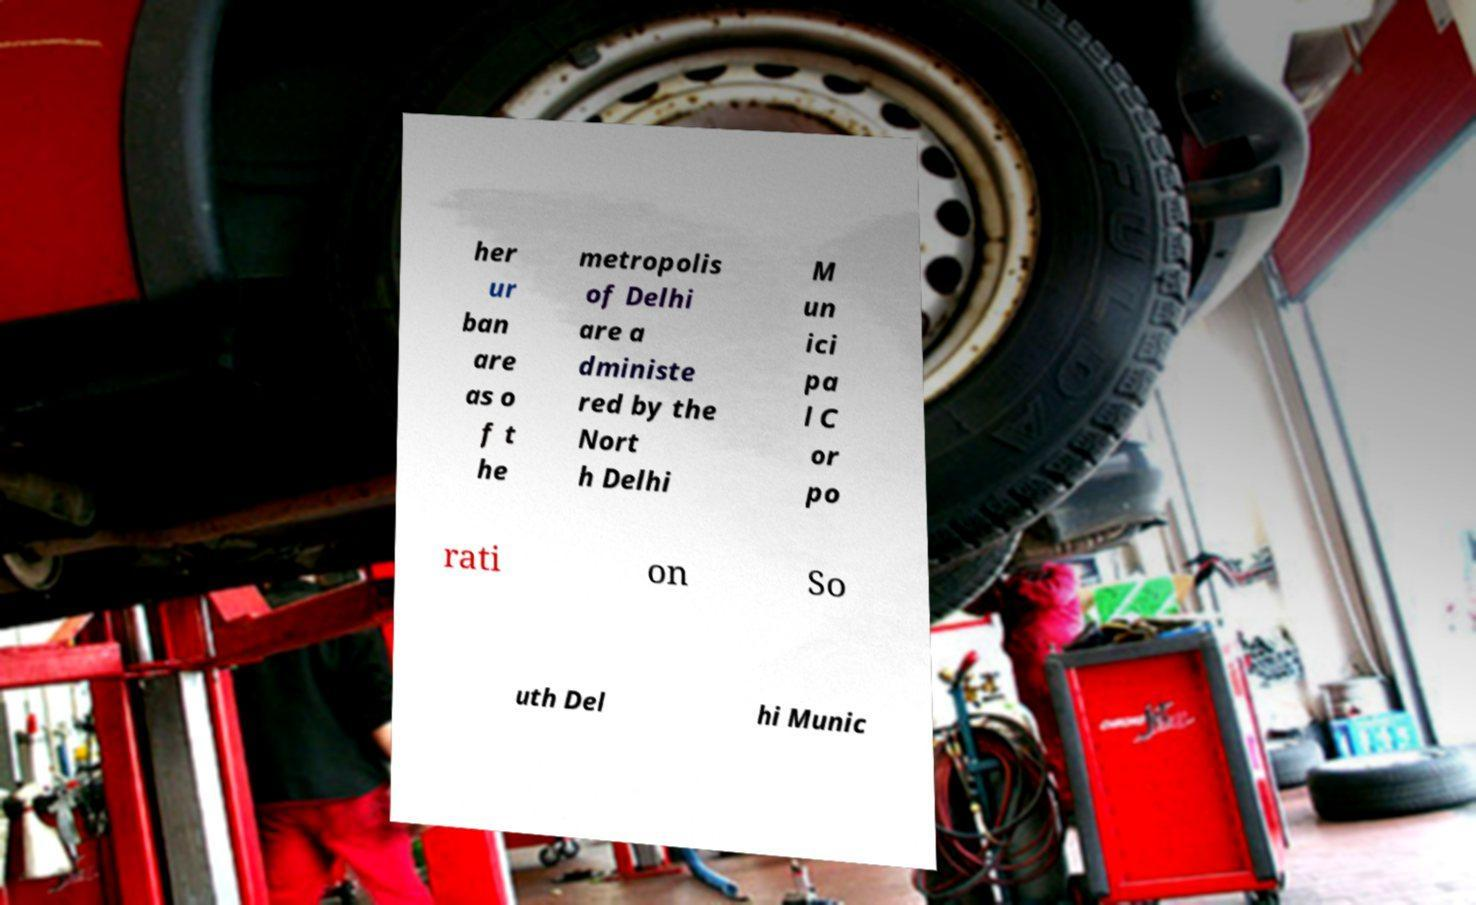I need the written content from this picture converted into text. Can you do that? her ur ban are as o f t he metropolis of Delhi are a dministe red by the Nort h Delhi M un ici pa l C or po rati on So uth Del hi Munic 